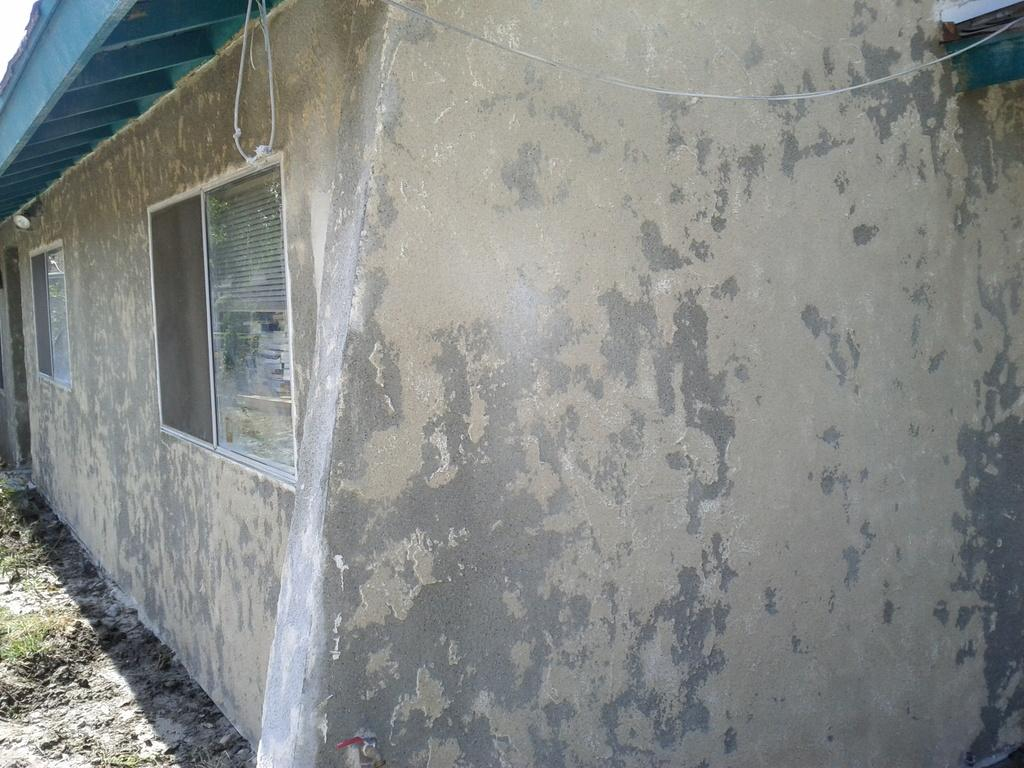What type of structure is visible in the image? There is a small house in the image. What is located in front of the house? There is a wall in front of the house. What feature can be seen on the wall? The wall has windows. What color is the roof of the house? The roof of the house is blue. What is the price of the throne in the image? There is no throne present in the image, so it is not possible to determine its price. 